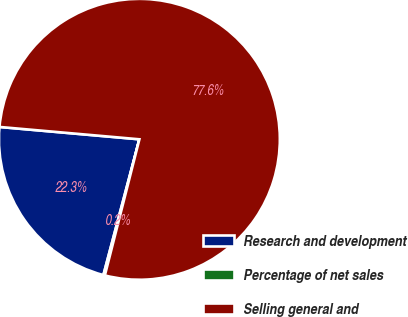Convert chart. <chart><loc_0><loc_0><loc_500><loc_500><pie_chart><fcel>Research and development<fcel>Percentage of net sales<fcel>Selling general and<nl><fcel>22.28%<fcel>0.17%<fcel>77.56%<nl></chart> 